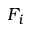Convert formula to latex. <formula><loc_0><loc_0><loc_500><loc_500>F _ { i }</formula> 